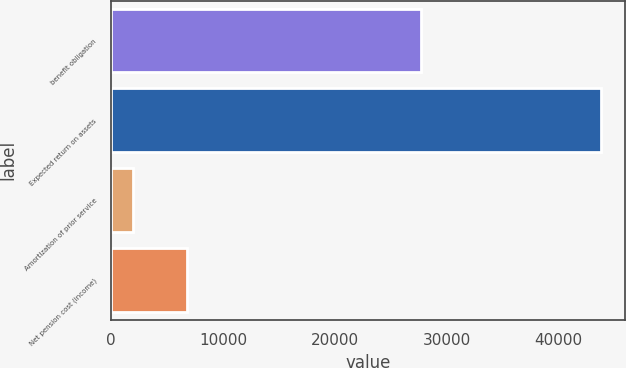Convert chart to OTSL. <chart><loc_0><loc_0><loc_500><loc_500><bar_chart><fcel>benefit obligation<fcel>Expected return on assets<fcel>Amortization of prior service<fcel>Net pension cost (income)<nl><fcel>27737<fcel>43827<fcel>1923<fcel>6776<nl></chart> 